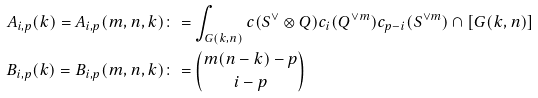Convert formula to latex. <formula><loc_0><loc_0><loc_500><loc_500>A _ { i , p } ( k ) = A _ { i , p } ( m , n , k ) & \colon = \int _ { G ( k , n ) } c ( S ^ { \vee } \otimes Q ) c _ { i } ( Q ^ { \vee m } ) c _ { p - i } ( S ^ { \vee m } ) \cap [ G ( k , n ) ] \\ B _ { i , p } ( k ) = B _ { i , p } ( m , n , k ) & \colon = \binom { m ( n - k ) - p } { i - p }</formula> 